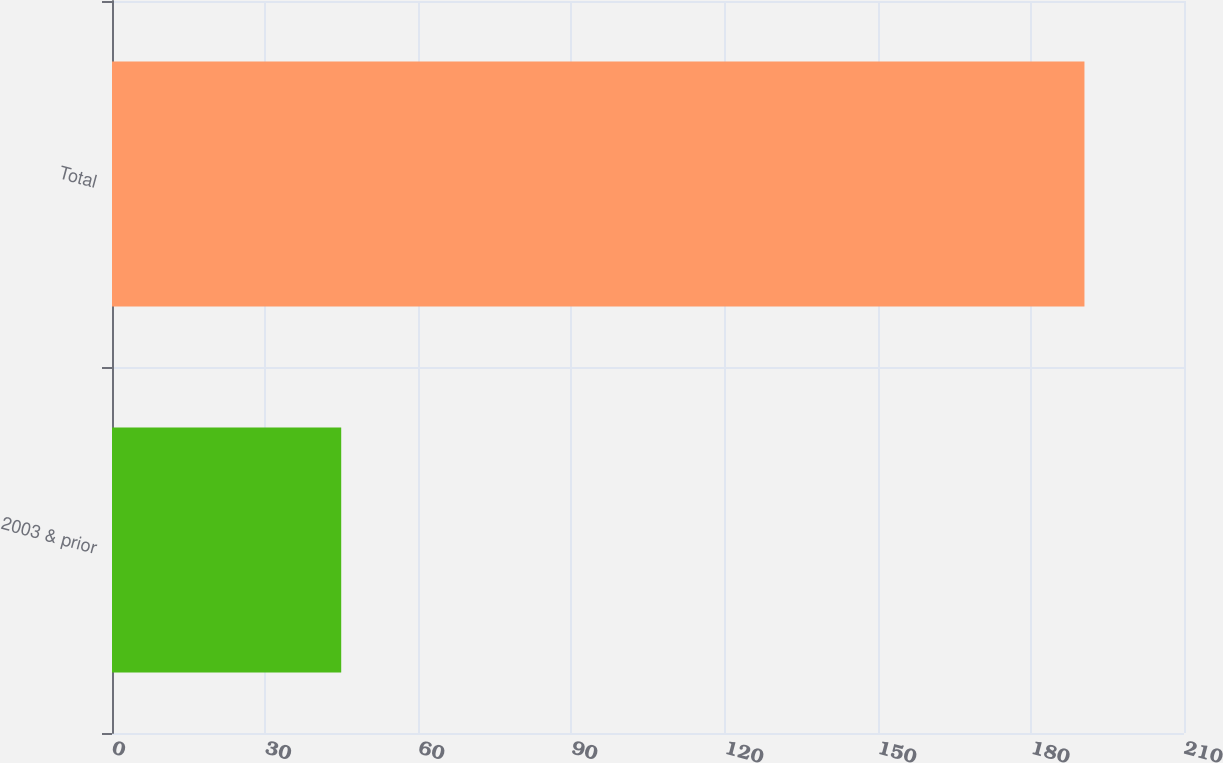Convert chart to OTSL. <chart><loc_0><loc_0><loc_500><loc_500><bar_chart><fcel>2003 & prior<fcel>Total<nl><fcel>44.9<fcel>190.5<nl></chart> 